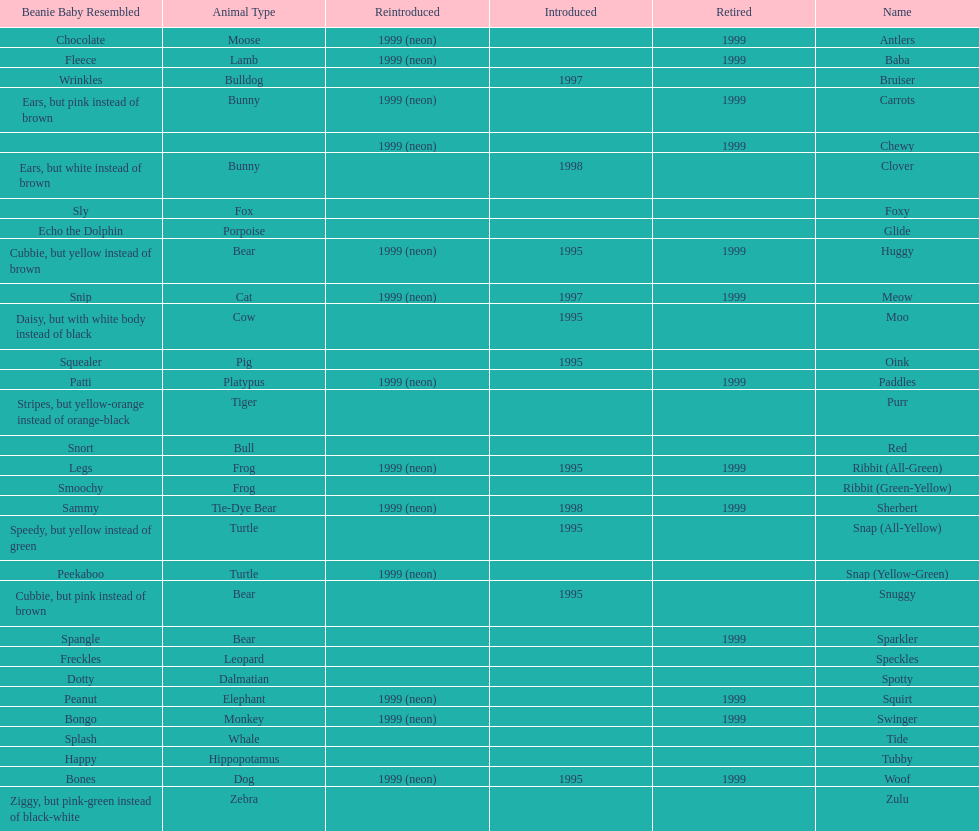How many monkey pillow pals were there? 1. 